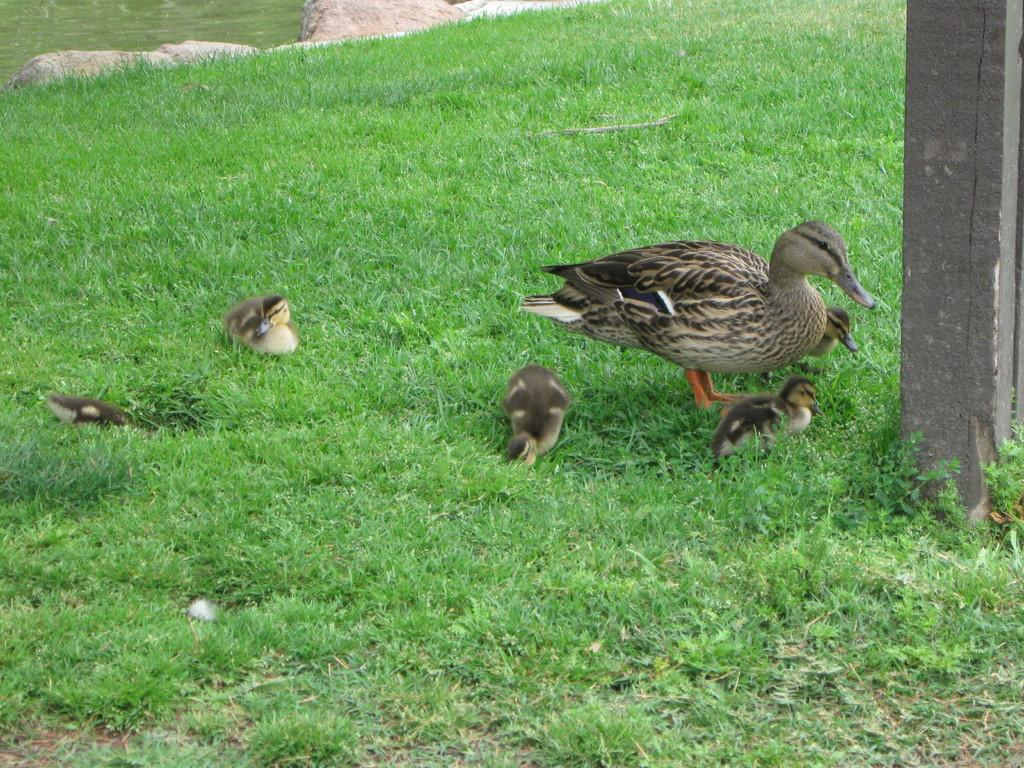What is there are any animals in the image? Yes, there are birds in the center of the image. What is the birds' location in relation to the grass? The birds are on the grass. What can be seen on the right side of the image? There is a pole on the right side of the image. Can you tell me how many kittens are playing with the birds in the image? There are no kittens present in the image; it only features birds on the grass. What type of drink is being consumed by the birds in the image? There is no drink being consumed by the birds in the image; they are simply standing on the grass. 